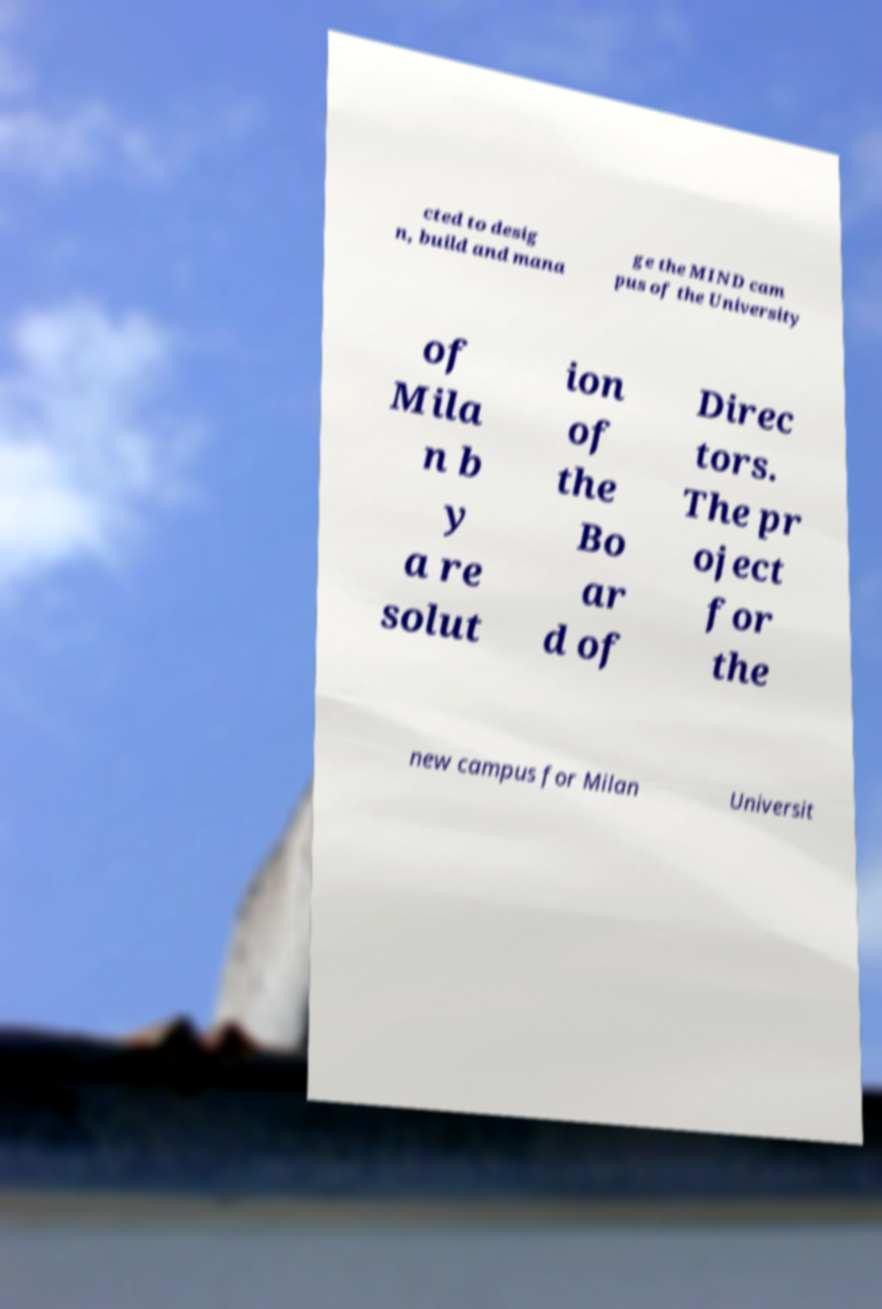For documentation purposes, I need the text within this image transcribed. Could you provide that? cted to desig n, build and mana ge the MIND cam pus of the University of Mila n b y a re solut ion of the Bo ar d of Direc tors. The pr oject for the new campus for Milan Universit 